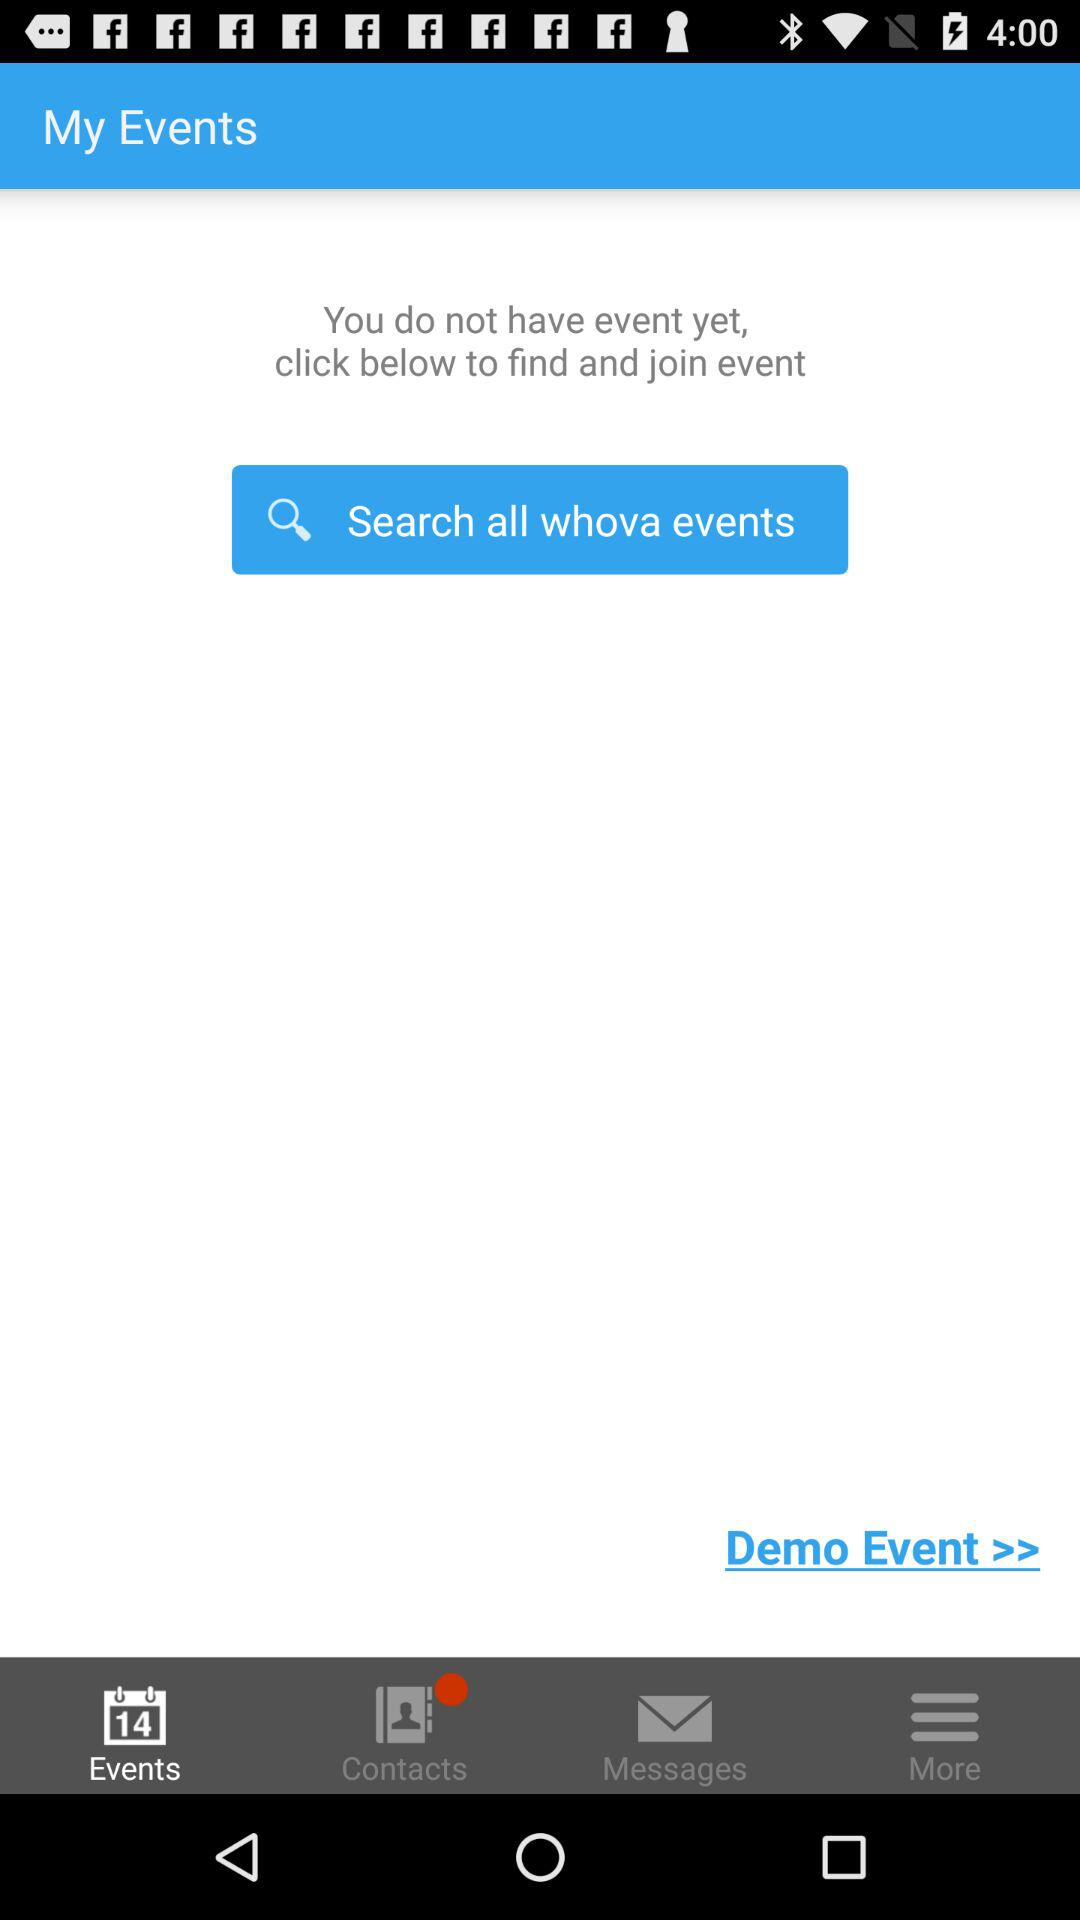What's the number of listed events? You do not have any listed events. 